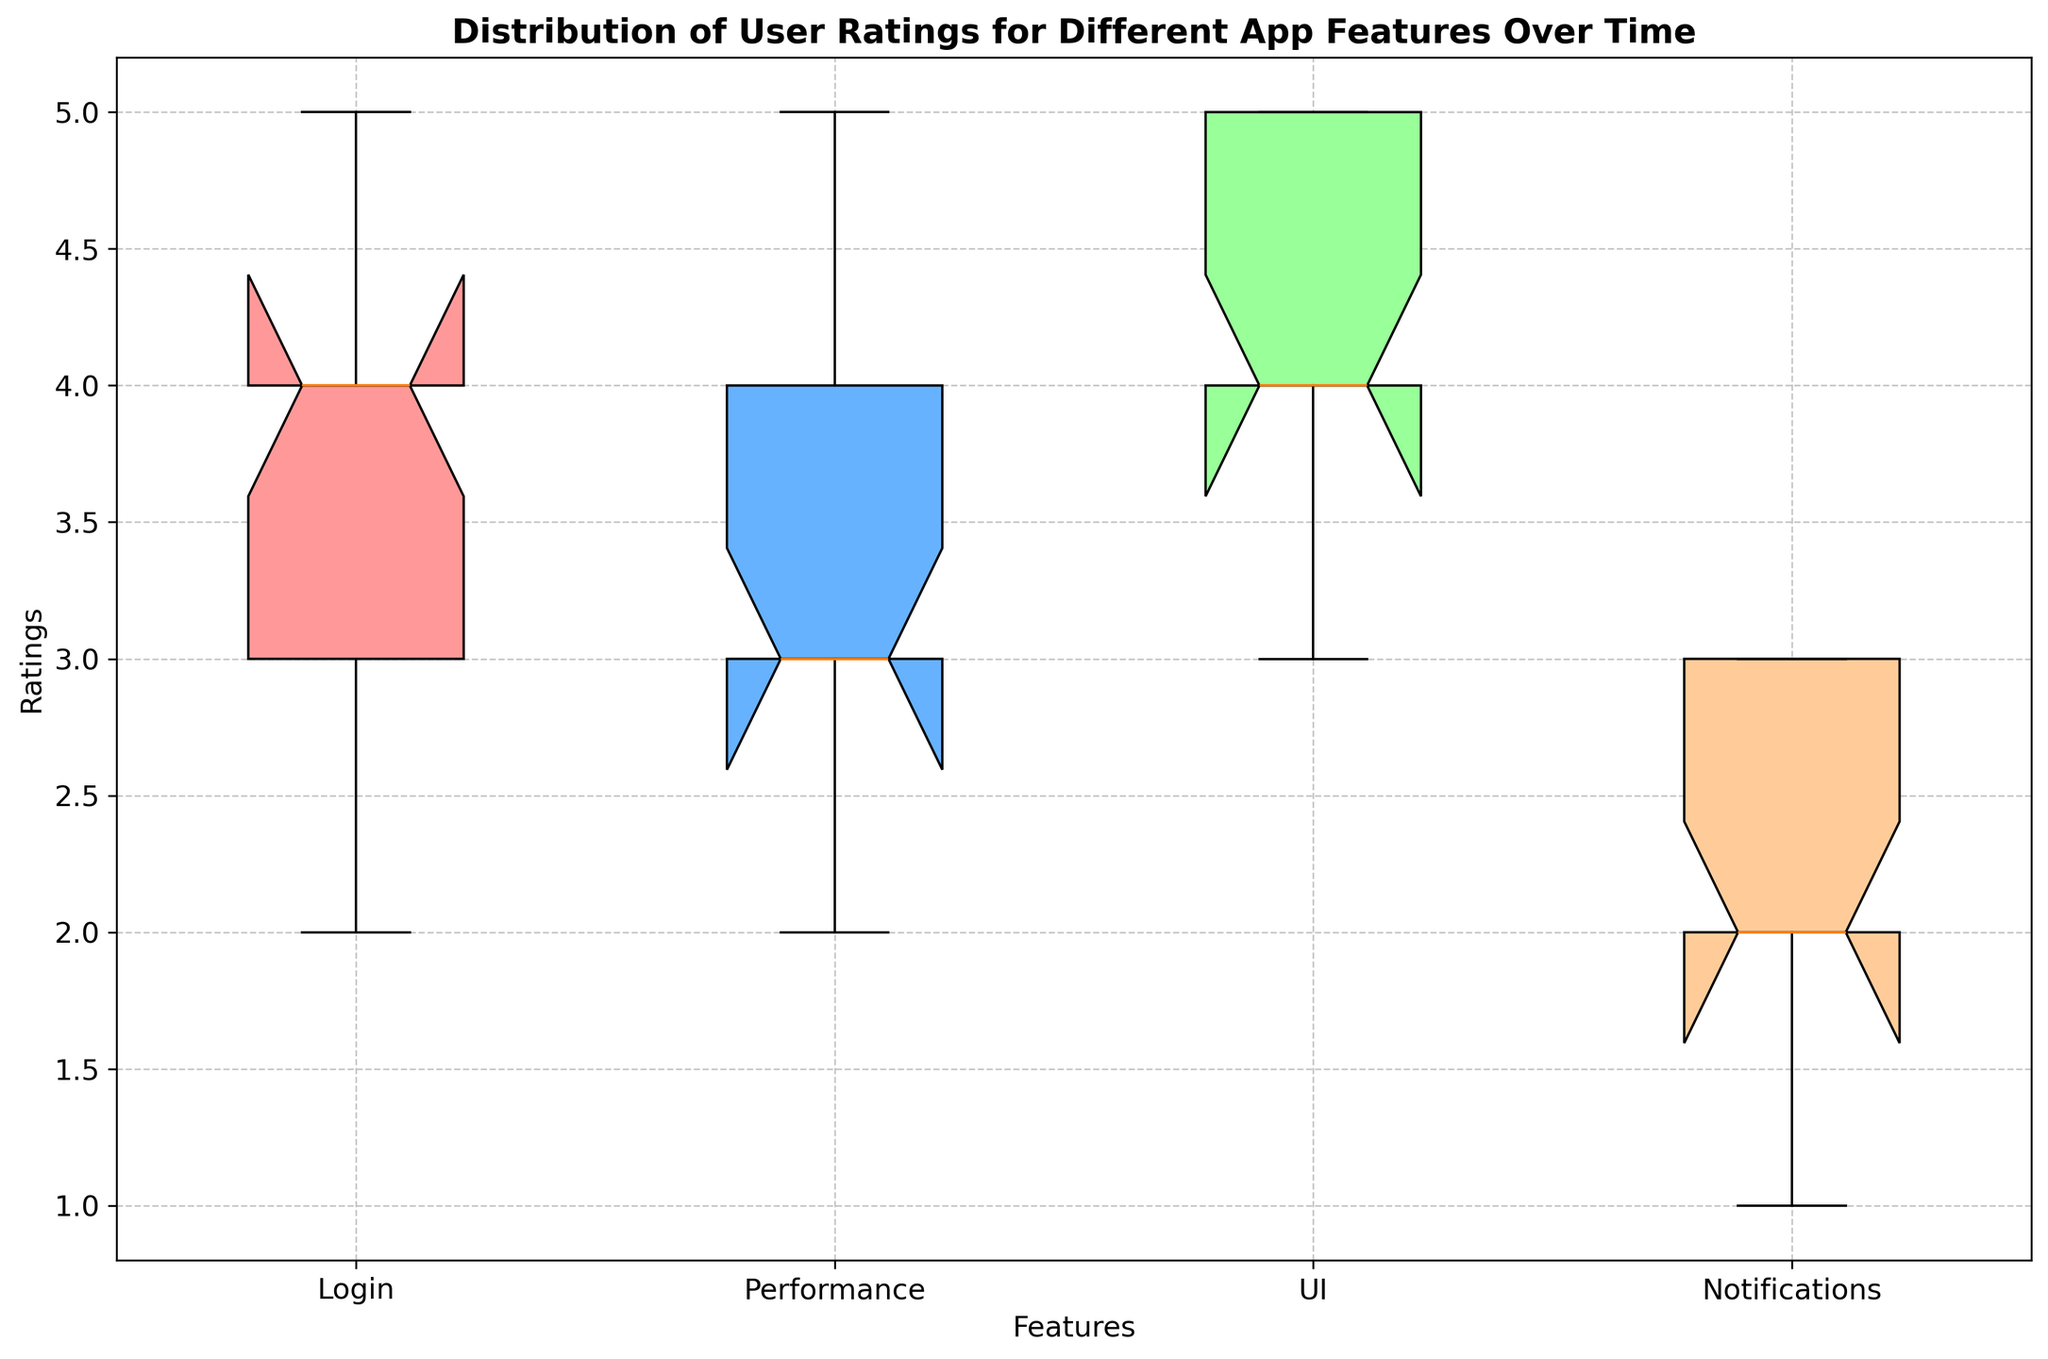Which feature has the highest median rating? Examine the central mark inside each box. The UI feature has the highest median rating compared to Login, Performance, and Notifications. The median is the central tendency indicator represented within the box.
Answer: UI Which feature has the least interquartile range (IQR)? The interquartile range (IQR) is the length of the box. The feature with the smallest box is 'UI', hence it has the least IQR. IQR is a measure of the middle 50% of the data.
Answer: UI Which feature shows the most variability in user ratings? The most variable feature will have the widest spread from the bottom to top whiskers. 'Notifications' shows the greatest range, indicating the most variability.
Answer: Notifications Are there any features with outliers? By observing the plot, we see that there are no specific outliers (points outside the whiskers) marked on the plot for any feature. Outliers would typically be marked by dots or stars outside the whiskers.
Answer: No Which feature has the lowest minimum rating? Look at the bottom of the whiskers representing the minimum value. 'Notifications' has the lowest minimum rating at around 1.
Answer: Notifications Compare the median ratings of 'Login' and 'Performance'. Which one is higher? The median is the line inside the box. By comparing, we see that the median for 'Login' is at 4 while for 'Performance', it is slightly below 4. Thus, 'Login' has a slightly higher median.
Answer: Login What is the median rating for the 'Login' feature? The median rating is represented by the line inside the 'Login' box. For 'Login', this line is at 4.
Answer: 4 What is the largest rating range observed and in which feature? The rating range is the distance between the bottom and top whiskers. 'Notifications' shows the largest range from approximately 1 to 3.
Answer: Notifications Compare the interquartile ranges (IQR) of 'UI' and 'Notifications'. Which one is broader? The IQR is the length of the boxes. 'Notifications' has a visibly wider box compared to 'UI', indicating a broader IQR.
Answer: Notifications 